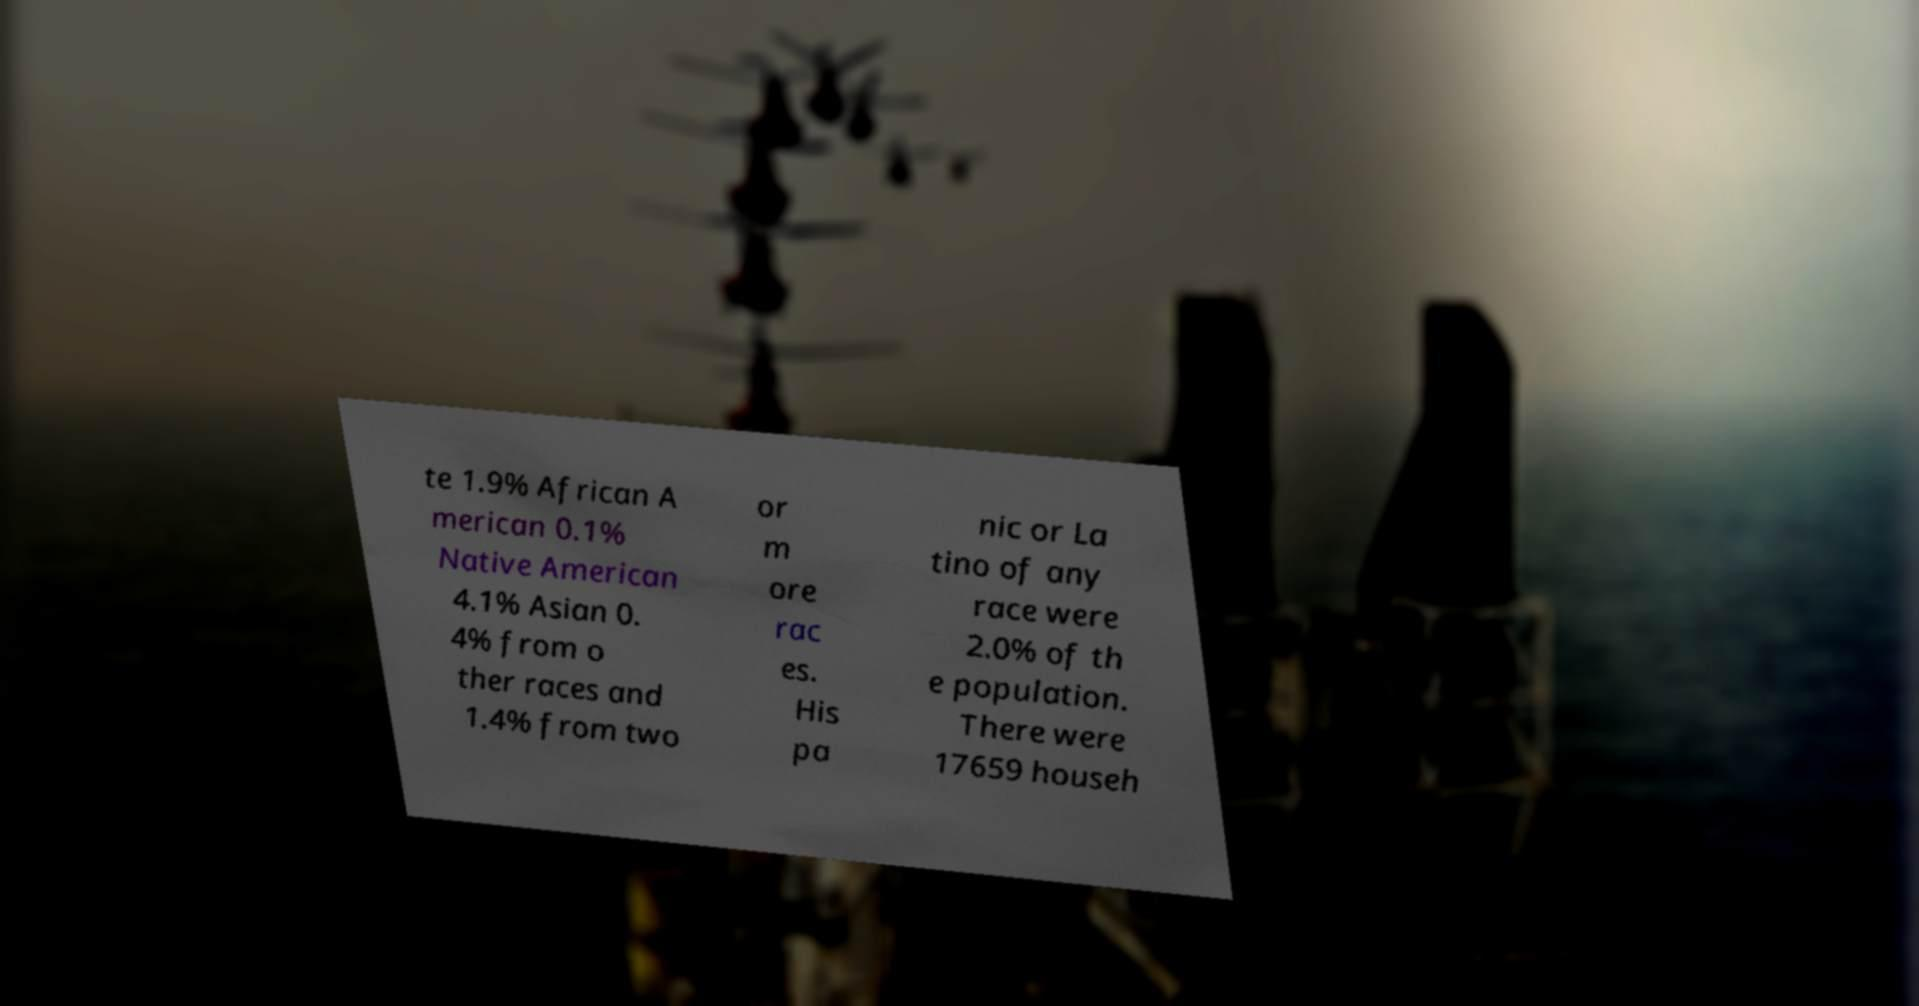There's text embedded in this image that I need extracted. Can you transcribe it verbatim? te 1.9% African A merican 0.1% Native American 4.1% Asian 0. 4% from o ther races and 1.4% from two or m ore rac es. His pa nic or La tino of any race were 2.0% of th e population. There were 17659 househ 